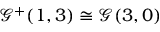Convert formula to latex. <formula><loc_0><loc_0><loc_500><loc_500>{ \mathcal { G } } ^ { + } ( 1 , 3 ) \cong { \mathcal { G } } ( 3 , 0 )</formula> 